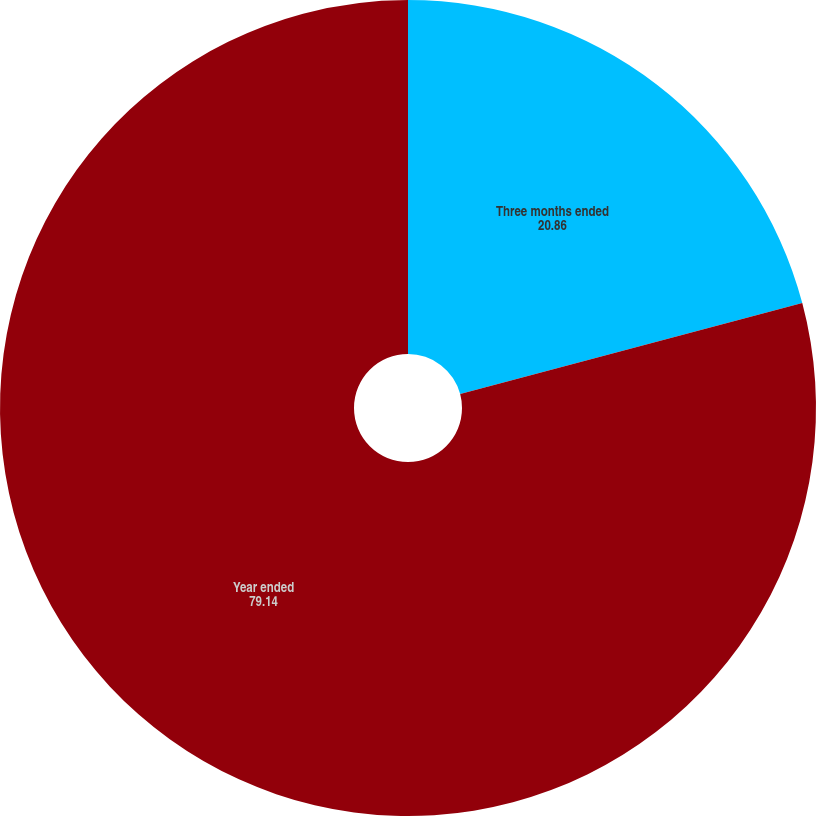<chart> <loc_0><loc_0><loc_500><loc_500><pie_chart><fcel>Three months ended<fcel>Year ended<nl><fcel>20.86%<fcel>79.14%<nl></chart> 